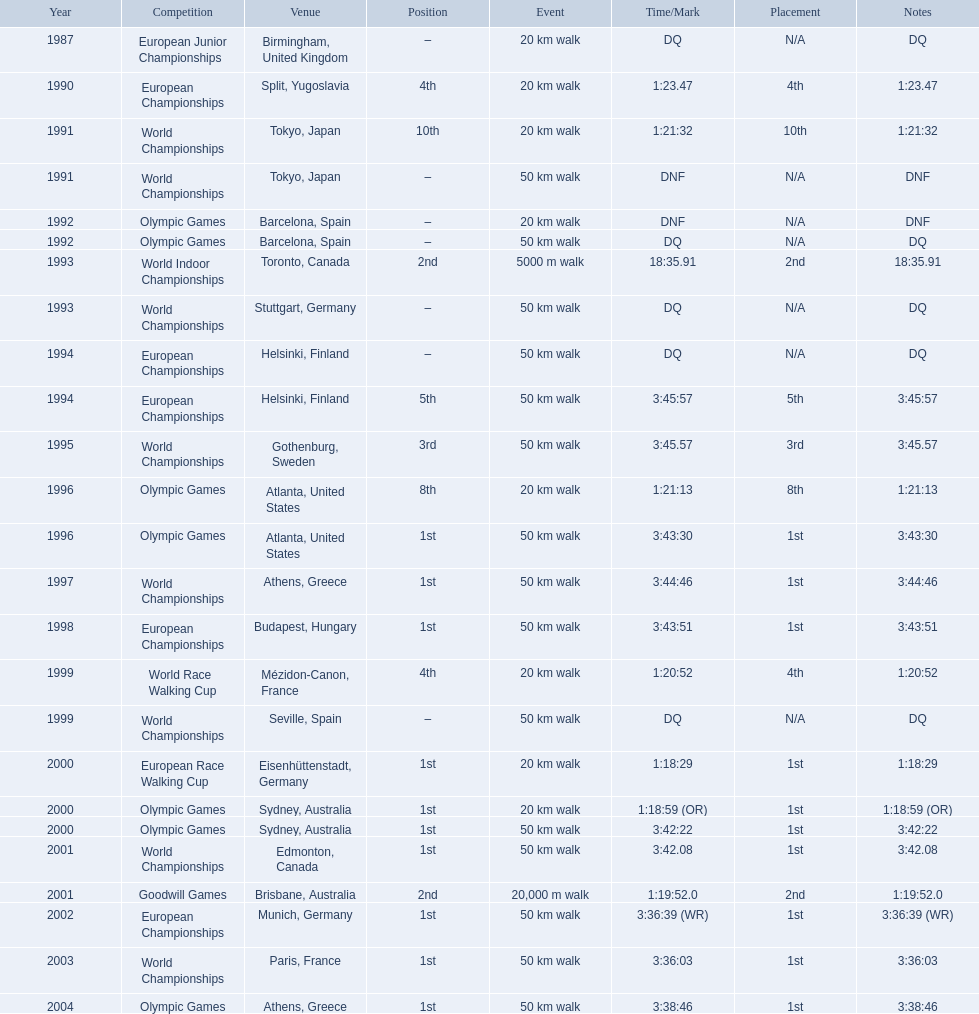Which of the competitions were 50 km walks? World Championships, Olympic Games, World Championships, European Championships, European Championships, World Championships, Olympic Games, World Championships, European Championships, World Championships, Olympic Games, World Championships, European Championships, World Championships, Olympic Games. Of these, which took place during or after the year 2000? Olympic Games, World Championships, European Championships, World Championships, Olympic Games. From these, which took place in athens, greece? Olympic Games. What was the time to finish for this competition? 3:38:46. 